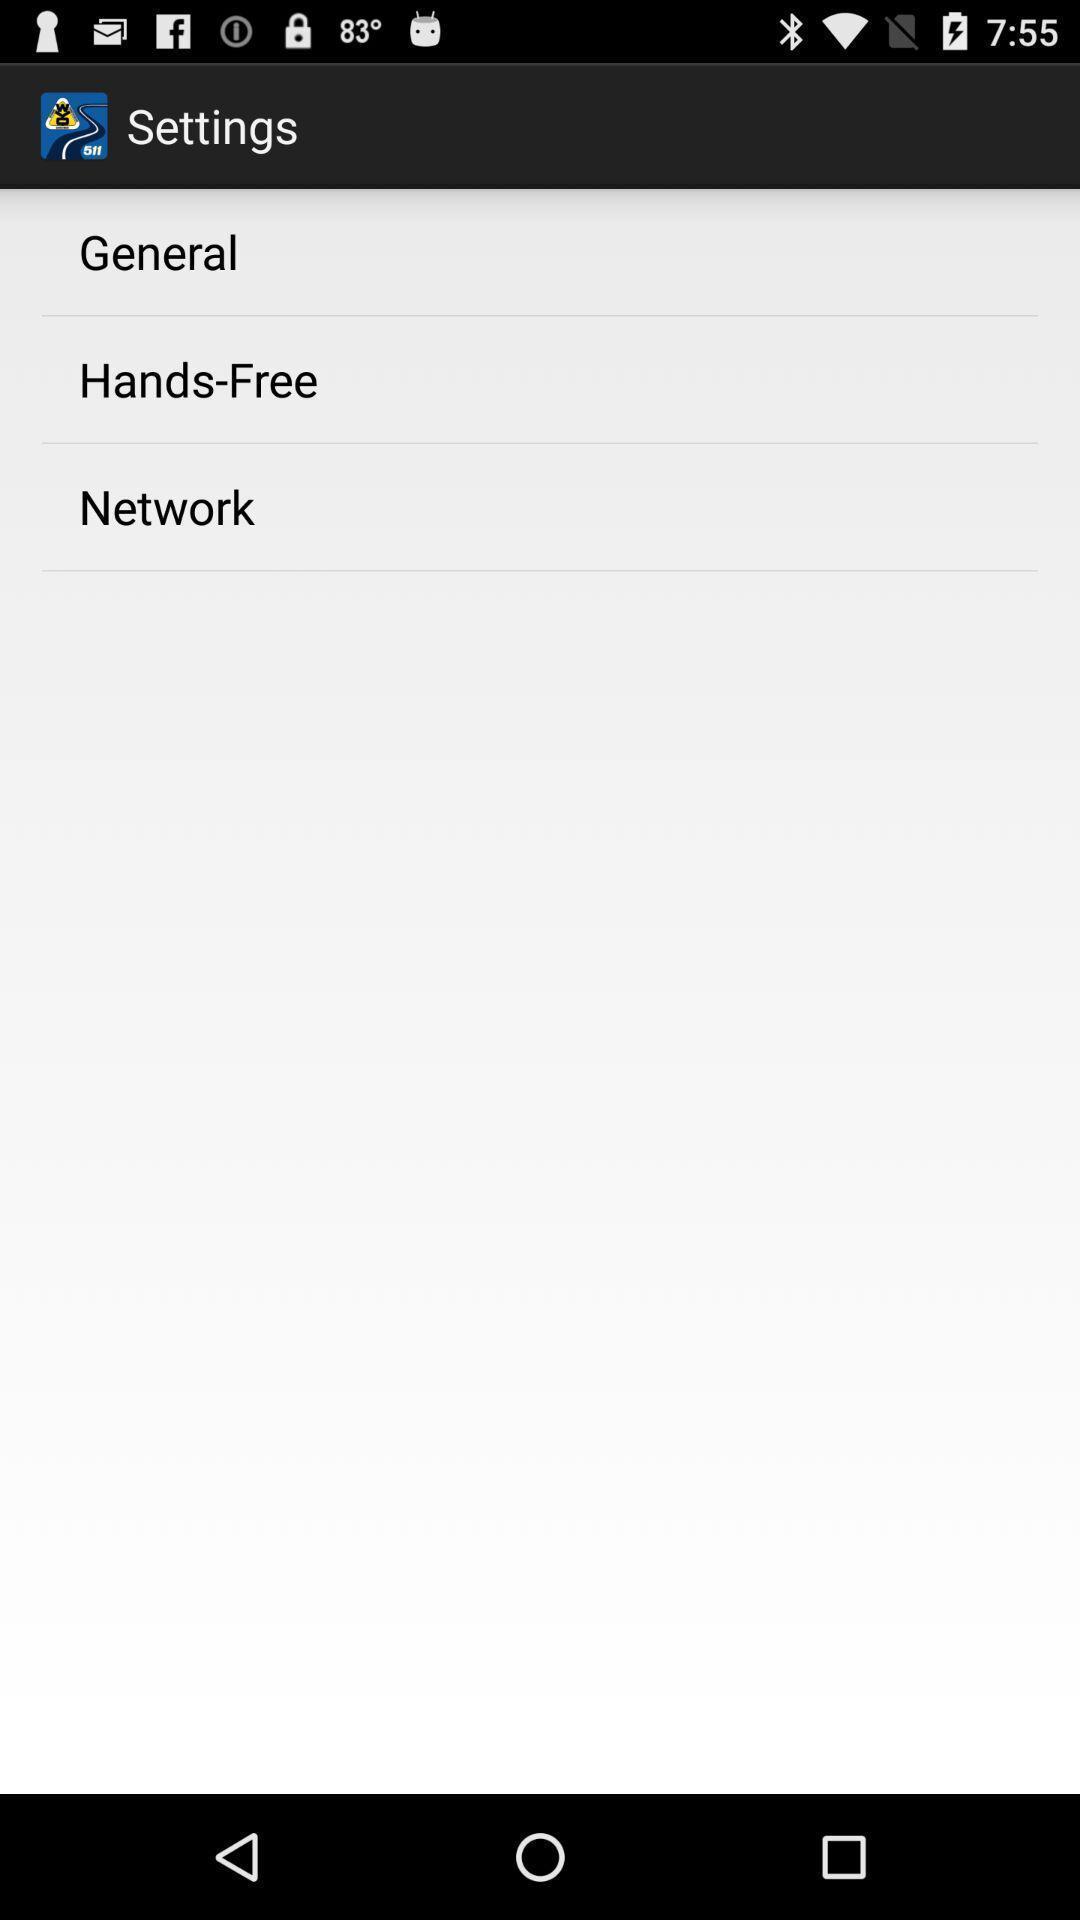Describe the key features of this screenshot. Screen showing settings page. 